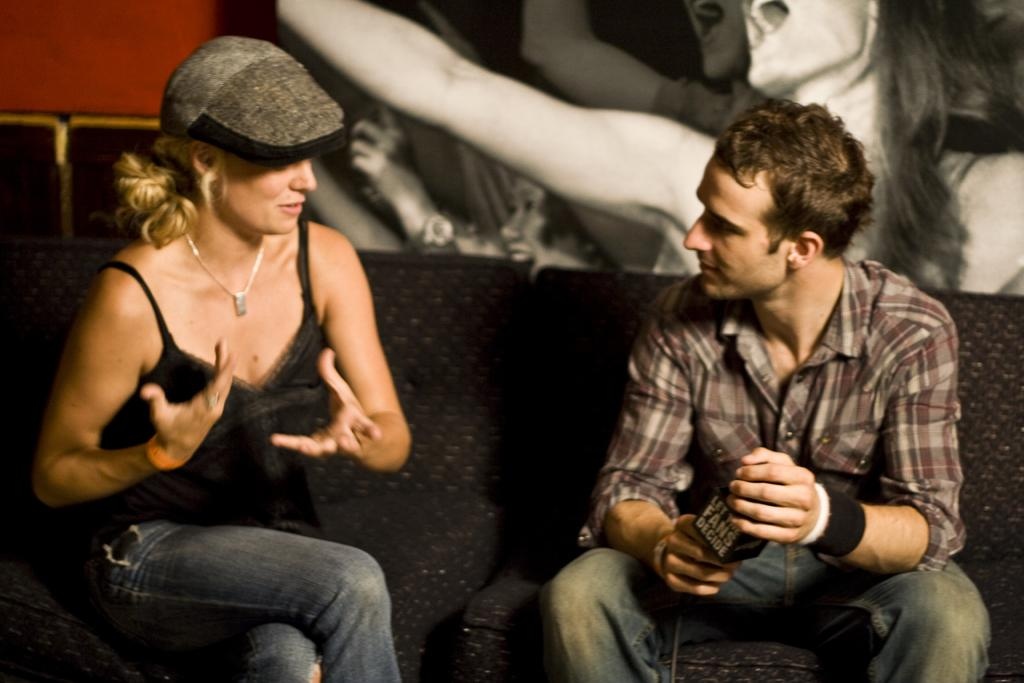Who is present in the image? There is a man and a woman in the image. What are the man and woman doing in the image? Both the man and woman are sitting on a sofa. What is the man holding in his hand? The man is holding a mic in his hand. What can be seen on the wall in the background? There is a poster on the wall in the background. What type of suit is the man wearing in the image? There is no mention of a suit in the image; the man is not wearing a suit. What is the topic of the discussion between the man and woman in the image? There is no indication of a discussion taking place in the image, as the man is holding a mic and the woman is sitting next to him. 